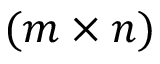<formula> <loc_0><loc_0><loc_500><loc_500>( m \times n )</formula> 